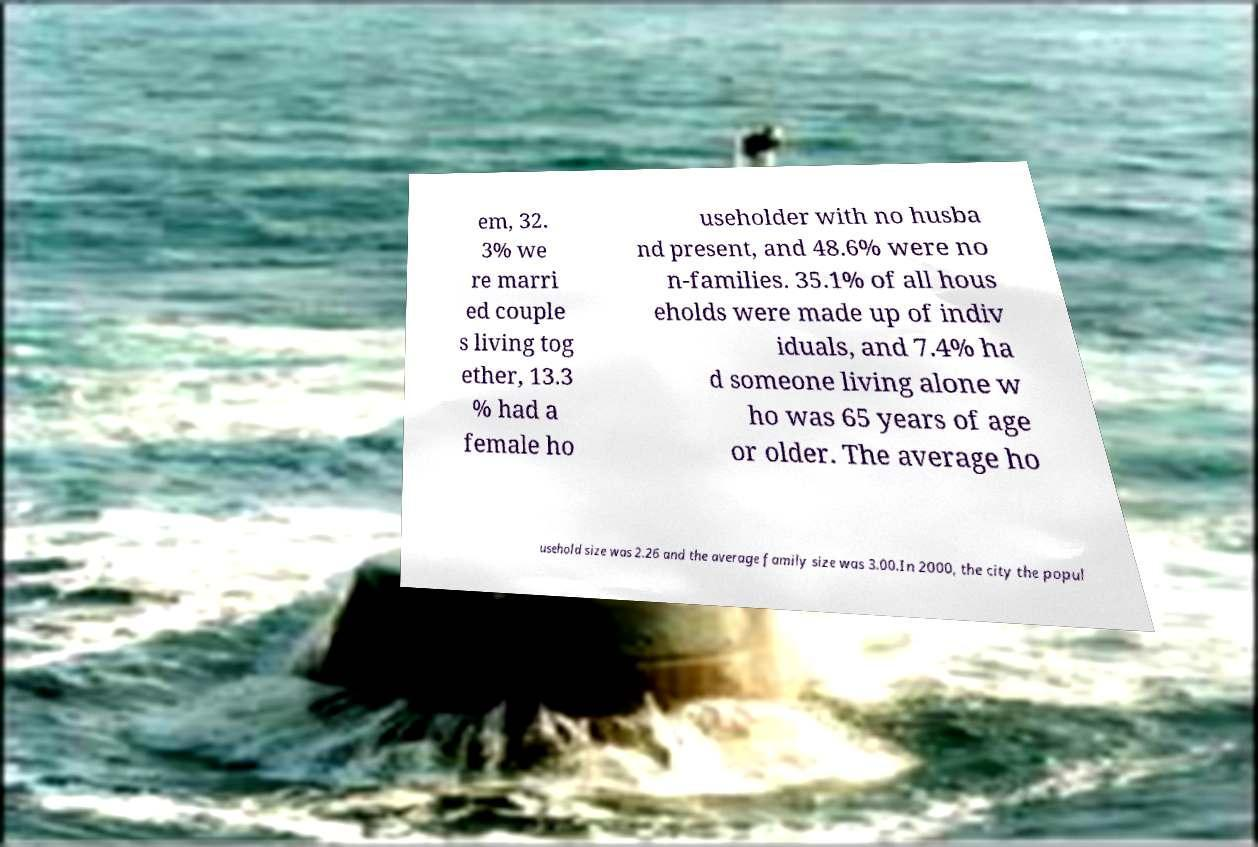Could you assist in decoding the text presented in this image and type it out clearly? em, 32. 3% we re marri ed couple s living tog ether, 13.3 % had a female ho useholder with no husba nd present, and 48.6% were no n-families. 35.1% of all hous eholds were made up of indiv iduals, and 7.4% ha d someone living alone w ho was 65 years of age or older. The average ho usehold size was 2.26 and the average family size was 3.00.In 2000, the city the popul 